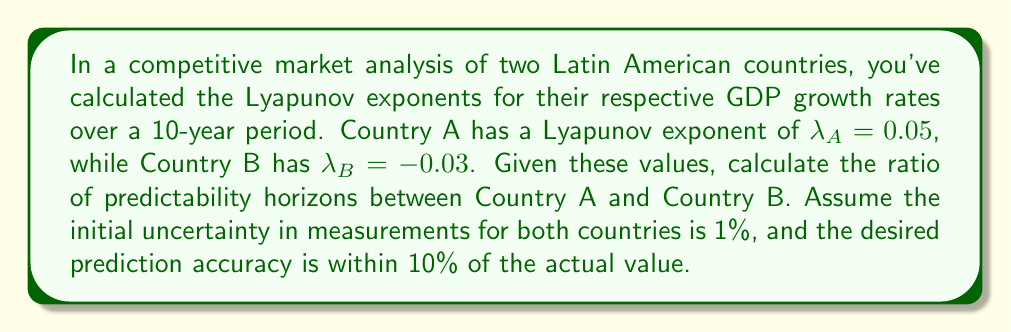Help me with this question. To solve this problem, we'll use the concept of Lyapunov time and predictability horizon:

1) The Lyapunov time ($T_L$) is given by the inverse of the absolute value of the Lyapunov exponent:
   
   $T_L = \frac{1}{|\lambda|}$

2) The predictability horizon ($T_P$) is calculated using:
   
   $T_P = T_L \cdot \ln(\frac{\delta_f}{\delta_0})$

   Where $\delta_f$ is the final acceptable uncertainty and $\delta_0$ is the initial uncertainty.

3) For Country A:
   $T_{LA} = \frac{1}{|0.05|} = 20$
   $T_{PA} = 20 \cdot \ln(\frac{0.1}{0.01}) = 20 \cdot \ln(10) \approx 46.05$

4) For Country B:
   $T_{LB} = \frac{1}{|-0.03|} = \frac{1}{0.03} \approx 33.33$
   $T_{PB} = 33.33 \cdot \ln(\frac{0.1}{0.01}) = 33.33 \cdot \ln(10) \approx 76.75$

5) The ratio of predictability horizons is:
   $\frac{T_{PB}}{T_{PA}} = \frac{76.75}{46.05} \approx 1.67$
Answer: 1.67 